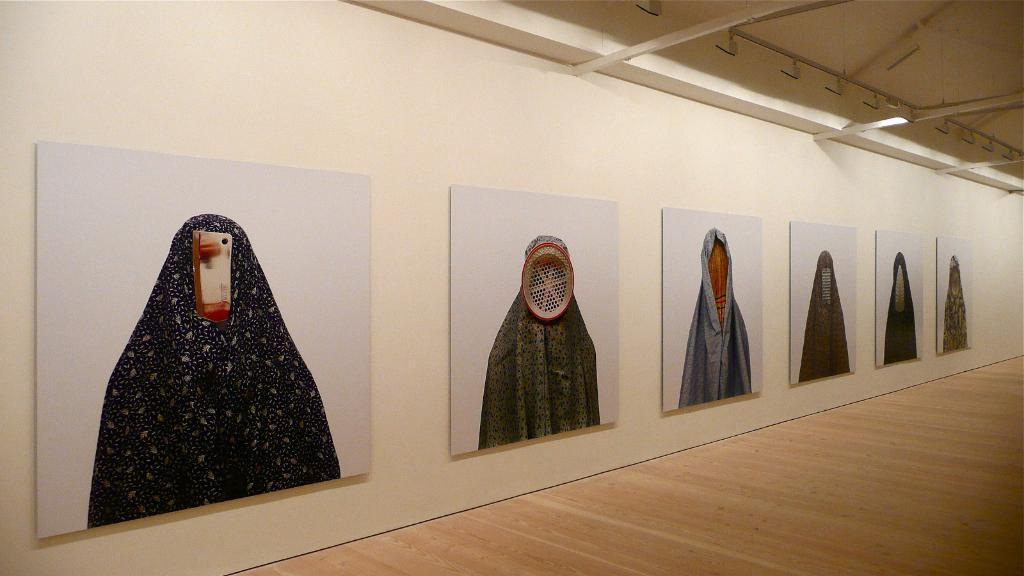What is attached to the wall in the image? There are boards attached to the wall in the image. What is the color of the wall? The wall is in white color. How many crows are sitting on the boards in the image? There are no crows present in the image; it only features boards attached to a white wall. What type of frame is surrounding the boards in the image? There is no frame surrounding the boards in the image; they are directly attached to the white wall. 